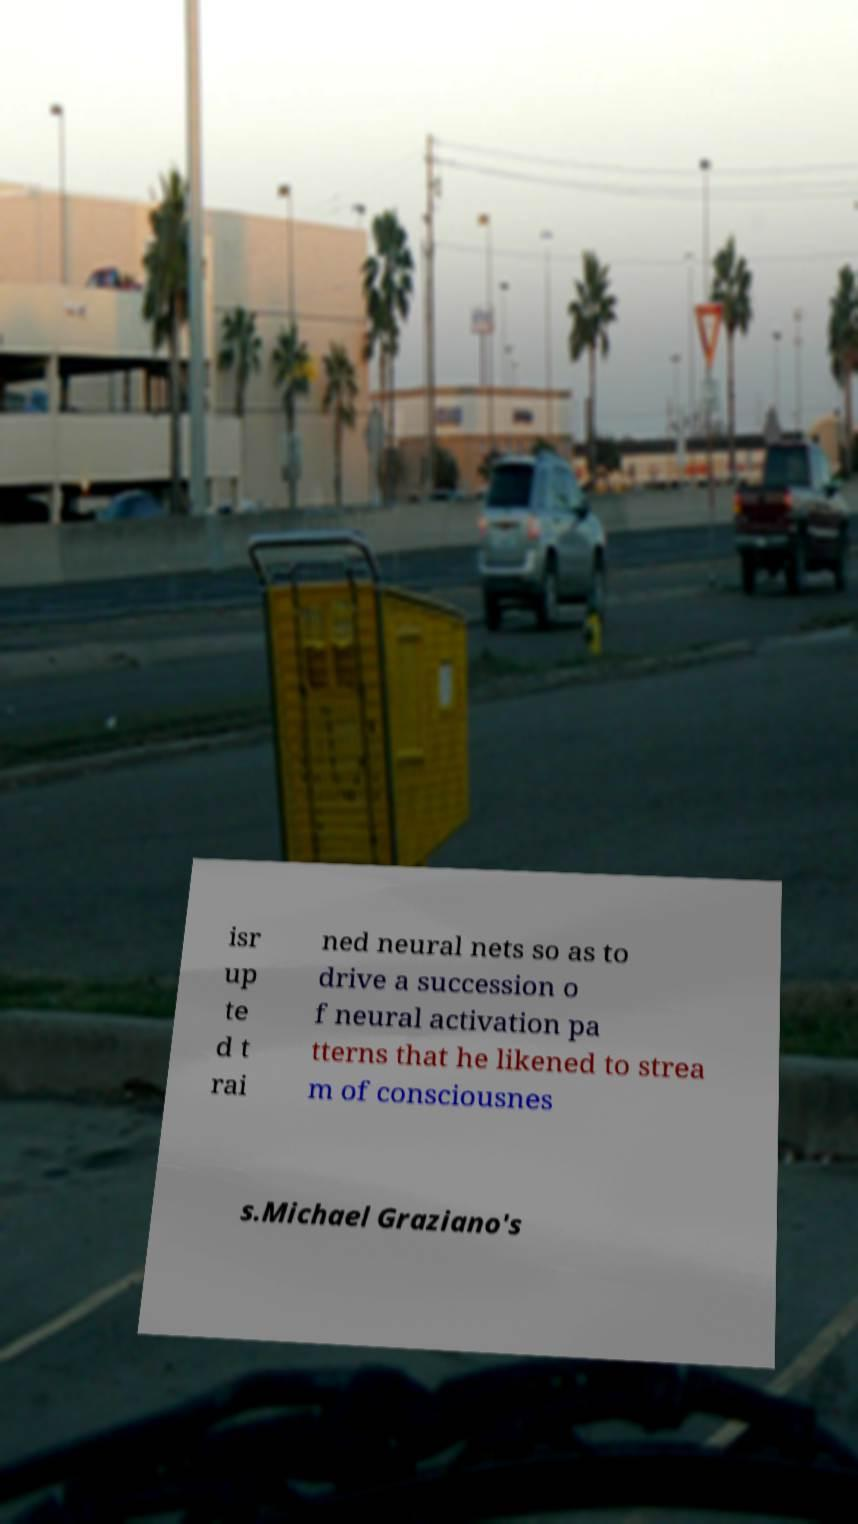Can you read and provide the text displayed in the image?This photo seems to have some interesting text. Can you extract and type it out for me? isr up te d t rai ned neural nets so as to drive a succession o f neural activation pa tterns that he likened to strea m of consciousnes s.Michael Graziano's 